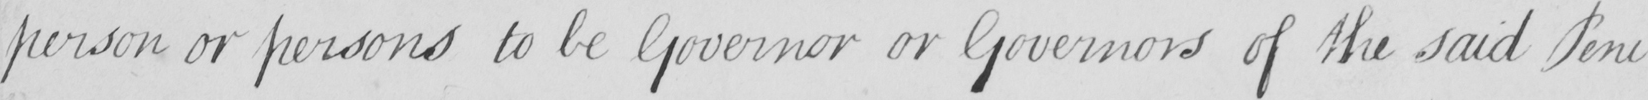Please transcribe the handwritten text in this image. person or persons to be Governor or Governors of the said Peni- 